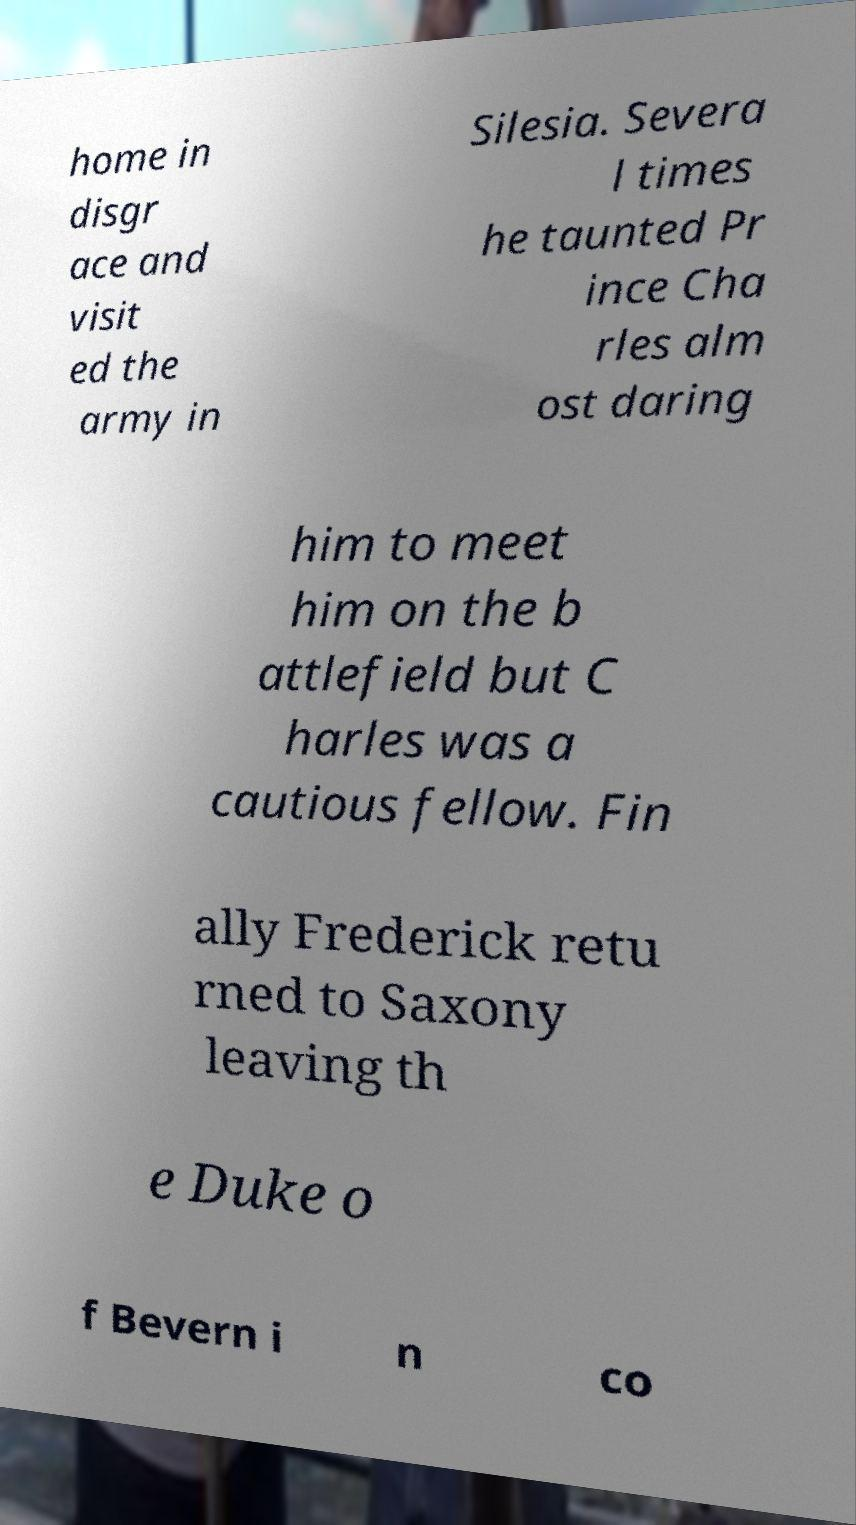Please identify and transcribe the text found in this image. home in disgr ace and visit ed the army in Silesia. Severa l times he taunted Pr ince Cha rles alm ost daring him to meet him on the b attlefield but C harles was a cautious fellow. Fin ally Frederick retu rned to Saxony leaving th e Duke o f Bevern i n co 